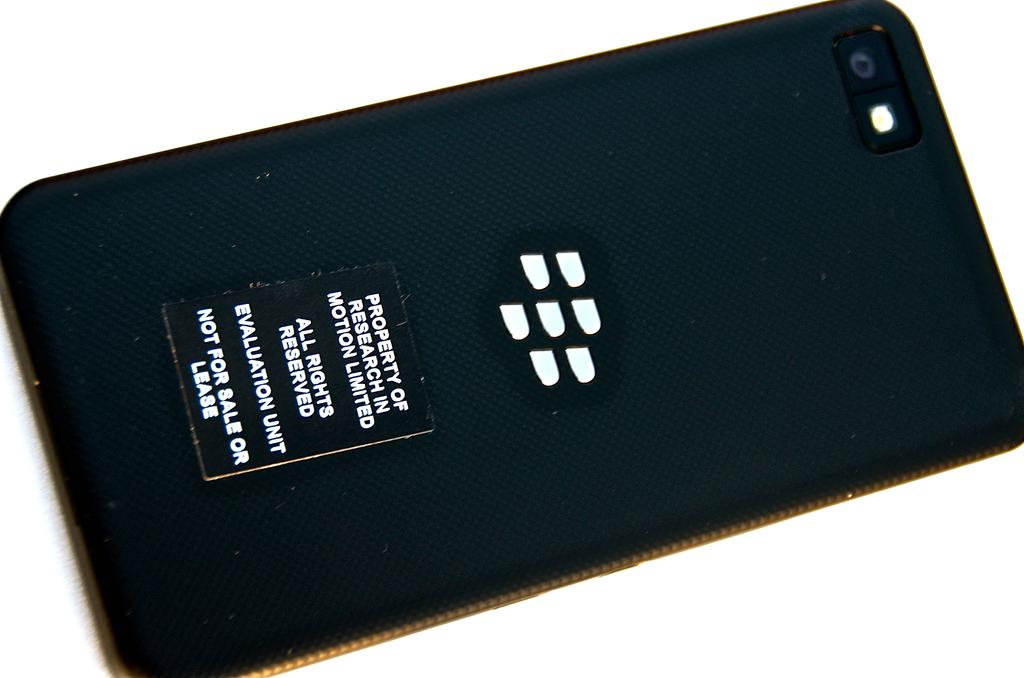<image>
Share a concise interpretation of the image provided. A BlackBerry has "Property of research in motion limited" on its back. 